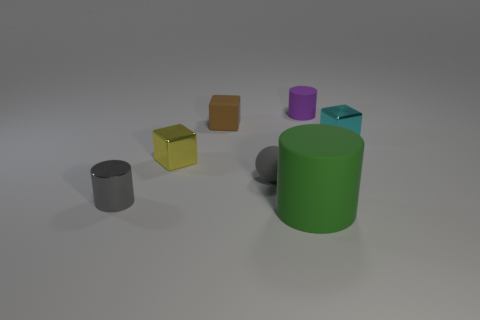Add 3 tiny gray cubes. How many objects exist? 10 Subtract all cylinders. How many objects are left? 4 Add 5 small purple spheres. How many small purple spheres exist? 5 Subtract 0 yellow cylinders. How many objects are left? 7 Subtract all tiny red shiny cylinders. Subtract all tiny brown cubes. How many objects are left? 6 Add 7 tiny gray objects. How many tiny gray objects are left? 9 